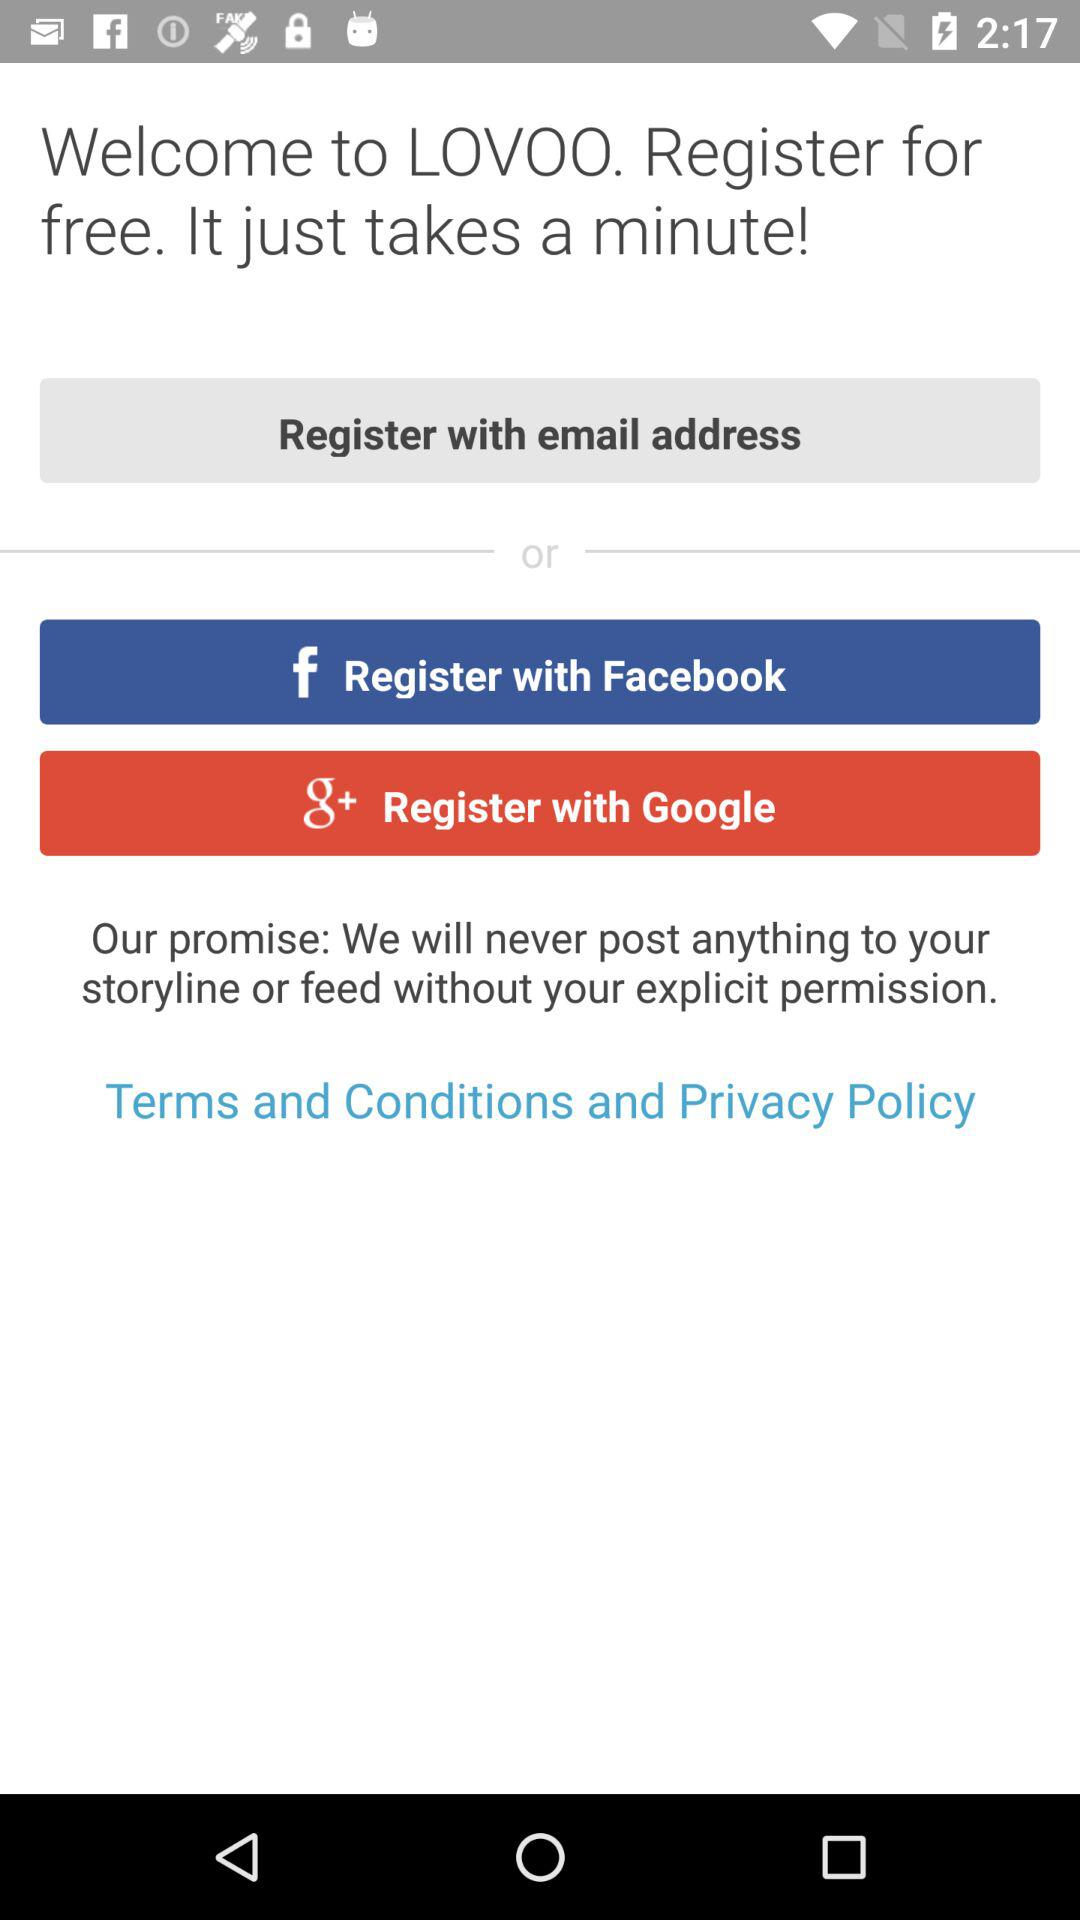What accounts can I use to register? You can use "email", "Facebook" and "Google+" accounts to register. 